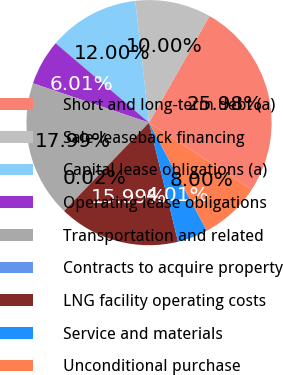Convert chart to OTSL. <chart><loc_0><loc_0><loc_500><loc_500><pie_chart><fcel>Short and long-term debt (a)<fcel>Sale-leaseback financing<fcel>Capital lease obligations (a)<fcel>Operating lease obligations<fcel>Transportation and related<fcel>Contracts to acquire property<fcel>LNG facility operating costs<fcel>Service and materials<fcel>Unconditional purchase<nl><fcel>25.98%<fcel>10.0%<fcel>12.0%<fcel>6.01%<fcel>17.99%<fcel>0.02%<fcel>15.99%<fcel>4.01%<fcel>8.0%<nl></chart> 